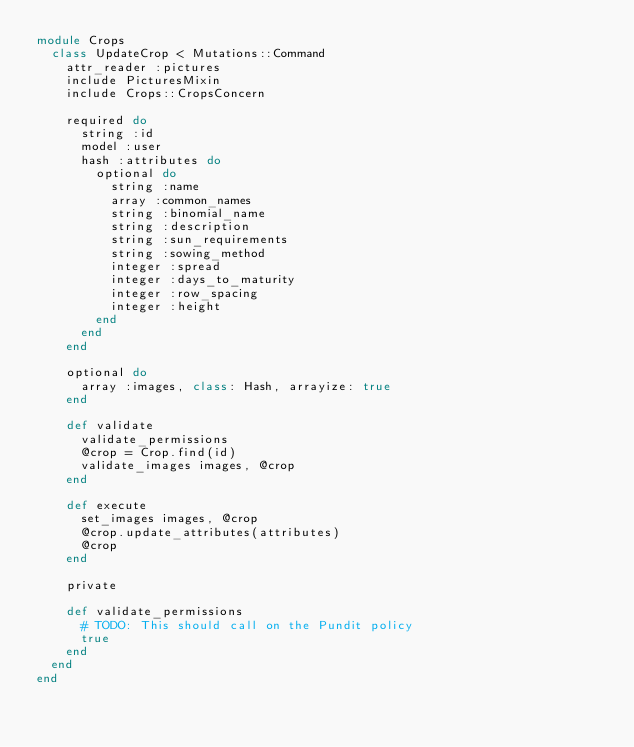<code> <loc_0><loc_0><loc_500><loc_500><_Ruby_>module Crops
  class UpdateCrop < Mutations::Command
    attr_reader :pictures
    include PicturesMixin
    include Crops::CropsConcern

    required do
      string :id
      model :user
      hash :attributes do
        optional do
          string :name
          array :common_names
          string :binomial_name
          string :description
          string :sun_requirements
          string :sowing_method
          integer :spread
          integer :days_to_maturity
          integer :row_spacing
          integer :height
        end
      end
    end

    optional do
      array :images, class: Hash, arrayize: true
    end

    def validate
      validate_permissions
      @crop = Crop.find(id)
      validate_images images, @crop
    end

    def execute
      set_images images, @crop
      @crop.update_attributes(attributes)
      @crop
    end

    private

    def validate_permissions
      # TODO: This should call on the Pundit policy
      true
    end
  end
end
</code> 